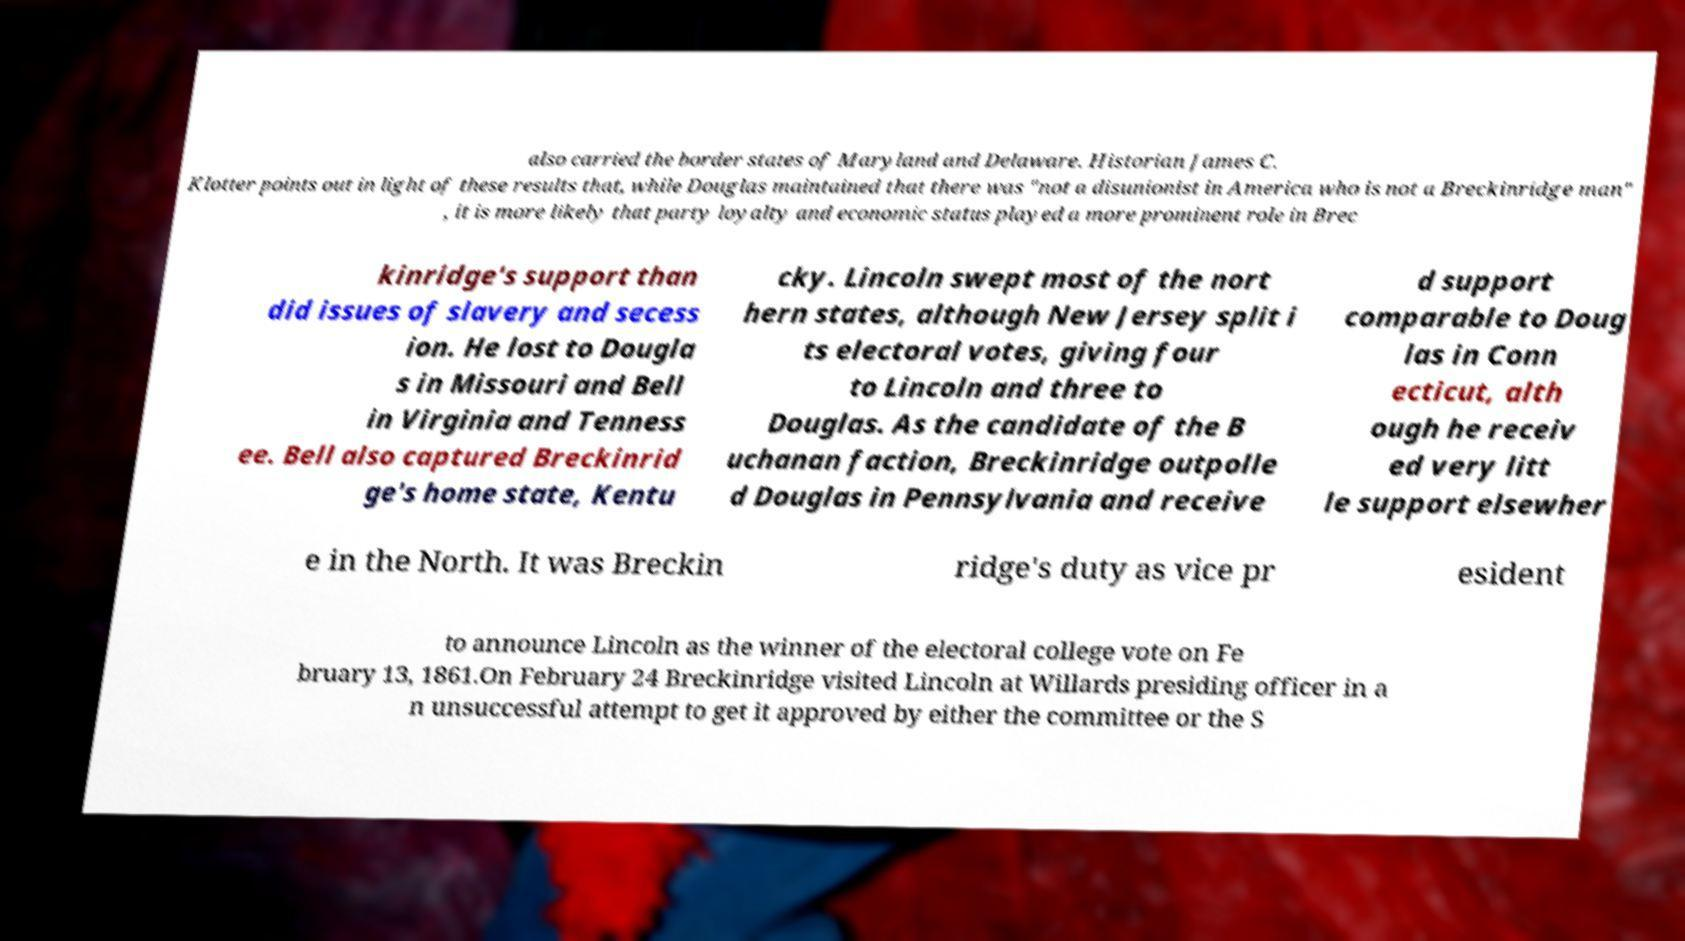Please read and relay the text visible in this image. What does it say? also carried the border states of Maryland and Delaware. Historian James C. Klotter points out in light of these results that, while Douglas maintained that there was "not a disunionist in America who is not a Breckinridge man" , it is more likely that party loyalty and economic status played a more prominent role in Brec kinridge's support than did issues of slavery and secess ion. He lost to Dougla s in Missouri and Bell in Virginia and Tenness ee. Bell also captured Breckinrid ge's home state, Kentu cky. Lincoln swept most of the nort hern states, although New Jersey split i ts electoral votes, giving four to Lincoln and three to Douglas. As the candidate of the B uchanan faction, Breckinridge outpolle d Douglas in Pennsylvania and receive d support comparable to Doug las in Conn ecticut, alth ough he receiv ed very litt le support elsewher e in the North. It was Breckin ridge's duty as vice pr esident to announce Lincoln as the winner of the electoral college vote on Fe bruary 13, 1861.On February 24 Breckinridge visited Lincoln at Willards presiding officer in a n unsuccessful attempt to get it approved by either the committee or the S 